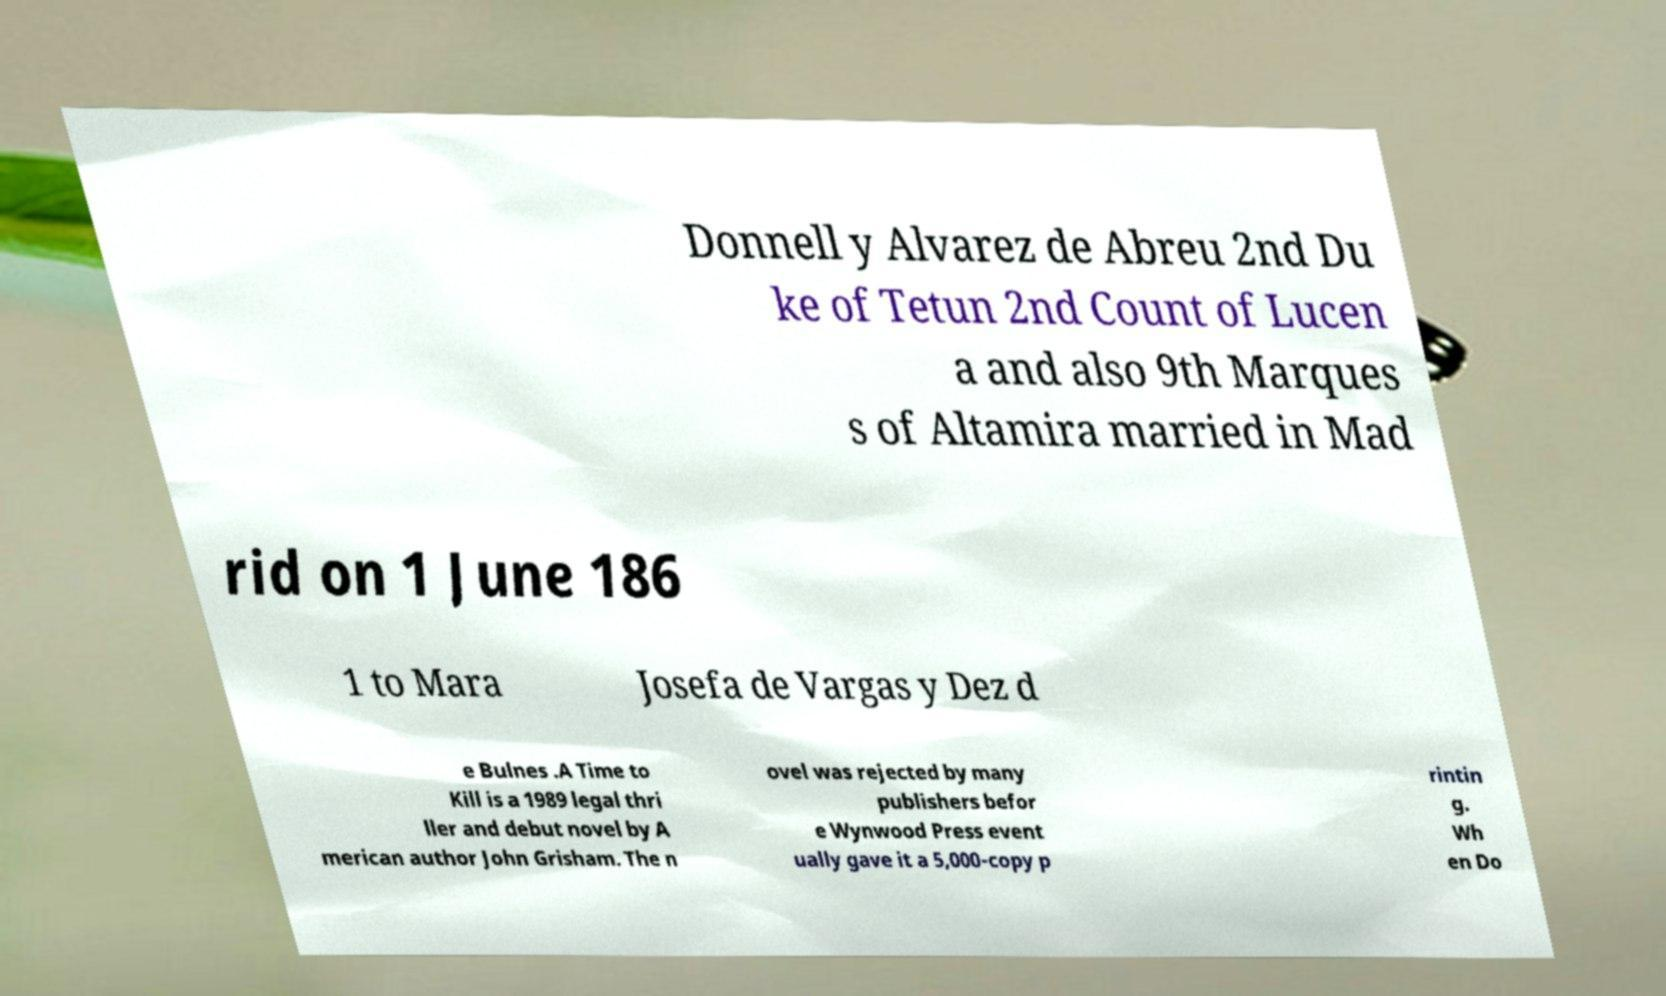There's text embedded in this image that I need extracted. Can you transcribe it verbatim? Donnell y Alvarez de Abreu 2nd Du ke of Tetun 2nd Count of Lucen a and also 9th Marques s of Altamira married in Mad rid on 1 June 186 1 to Mara Josefa de Vargas y Dez d e Bulnes .A Time to Kill is a 1989 legal thri ller and debut novel by A merican author John Grisham. The n ovel was rejected by many publishers befor e Wynwood Press event ually gave it a 5,000-copy p rintin g. Wh en Do 